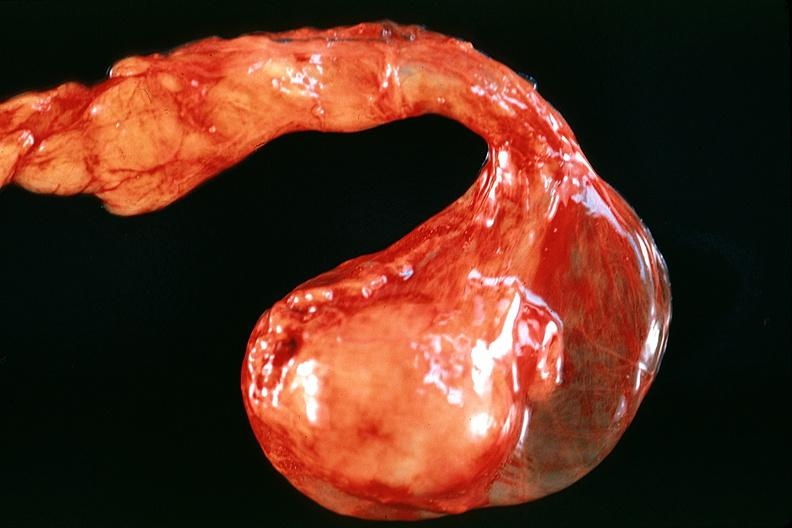what does this image show?
Answer the question using a single word or phrase. Testes 